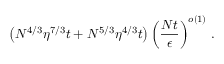Convert formula to latex. <formula><loc_0><loc_0><loc_500><loc_500>\left ( N ^ { 4 / 3 } \eta ^ { 7 / 3 } t + N ^ { 5 / 3 } \eta ^ { 4 / 3 } t \right ) \left ( \frac { N t } { \epsilon } \right ) ^ { o \left ( 1 \right ) } \, .</formula> 